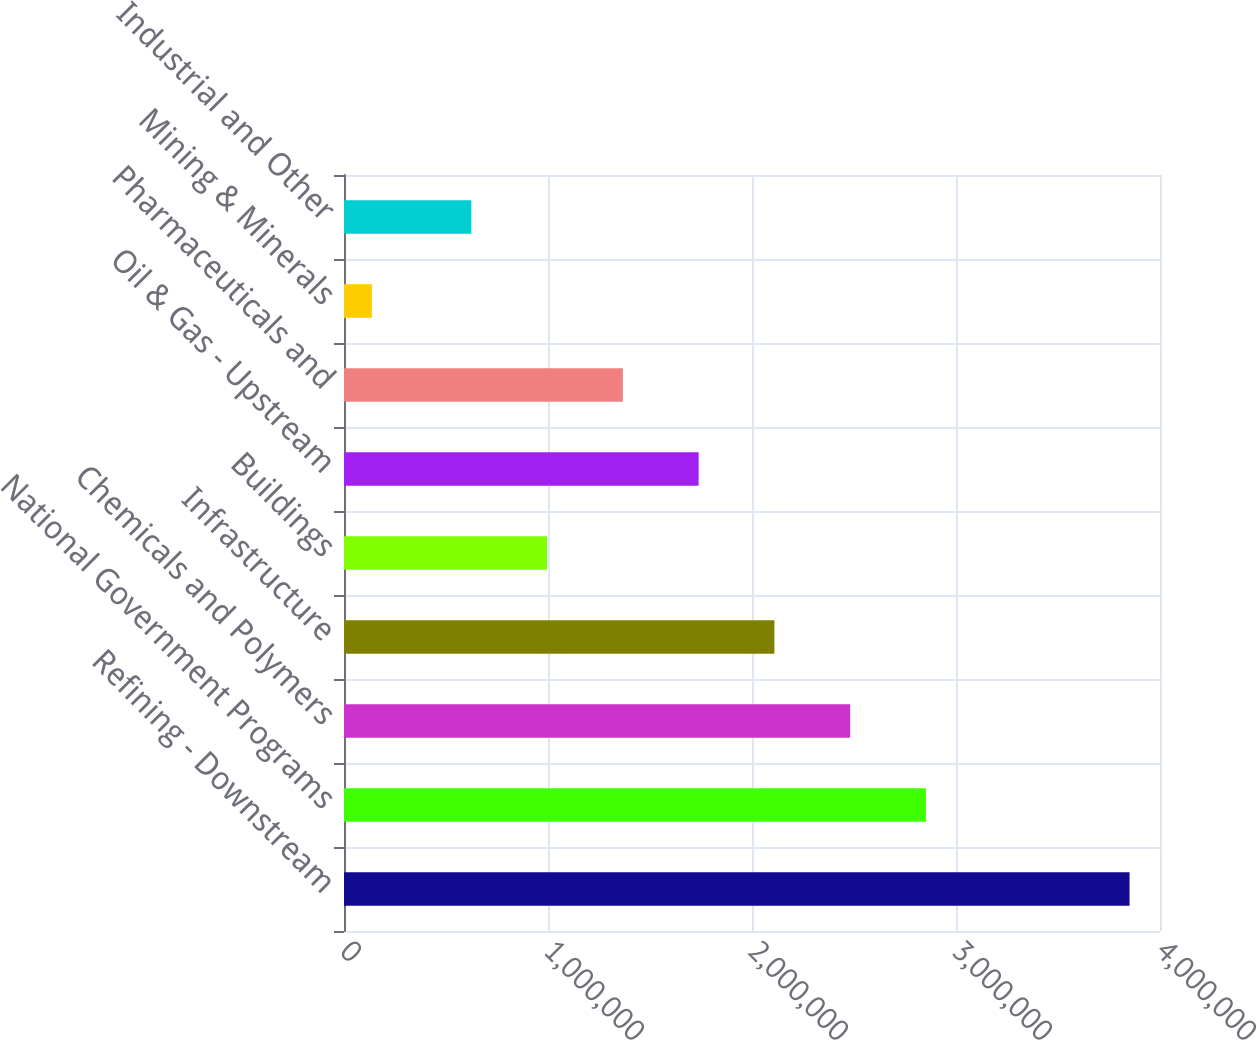Convert chart to OTSL. <chart><loc_0><loc_0><loc_500><loc_500><bar_chart><fcel>Refining - Downstream<fcel>National Government Programs<fcel>Chemicals and Polymers<fcel>Infrastructure<fcel>Buildings<fcel>Oil & Gas - Upstream<fcel>Pharmaceuticals and<fcel>Mining & Minerals<fcel>Industrial and Other<nl><fcel>3.85073e+06<fcel>2.85255e+06<fcel>2.48117e+06<fcel>2.10978e+06<fcel>995613<fcel>1.73839e+06<fcel>1.367e+06<fcel>136851<fcel>624225<nl></chart> 